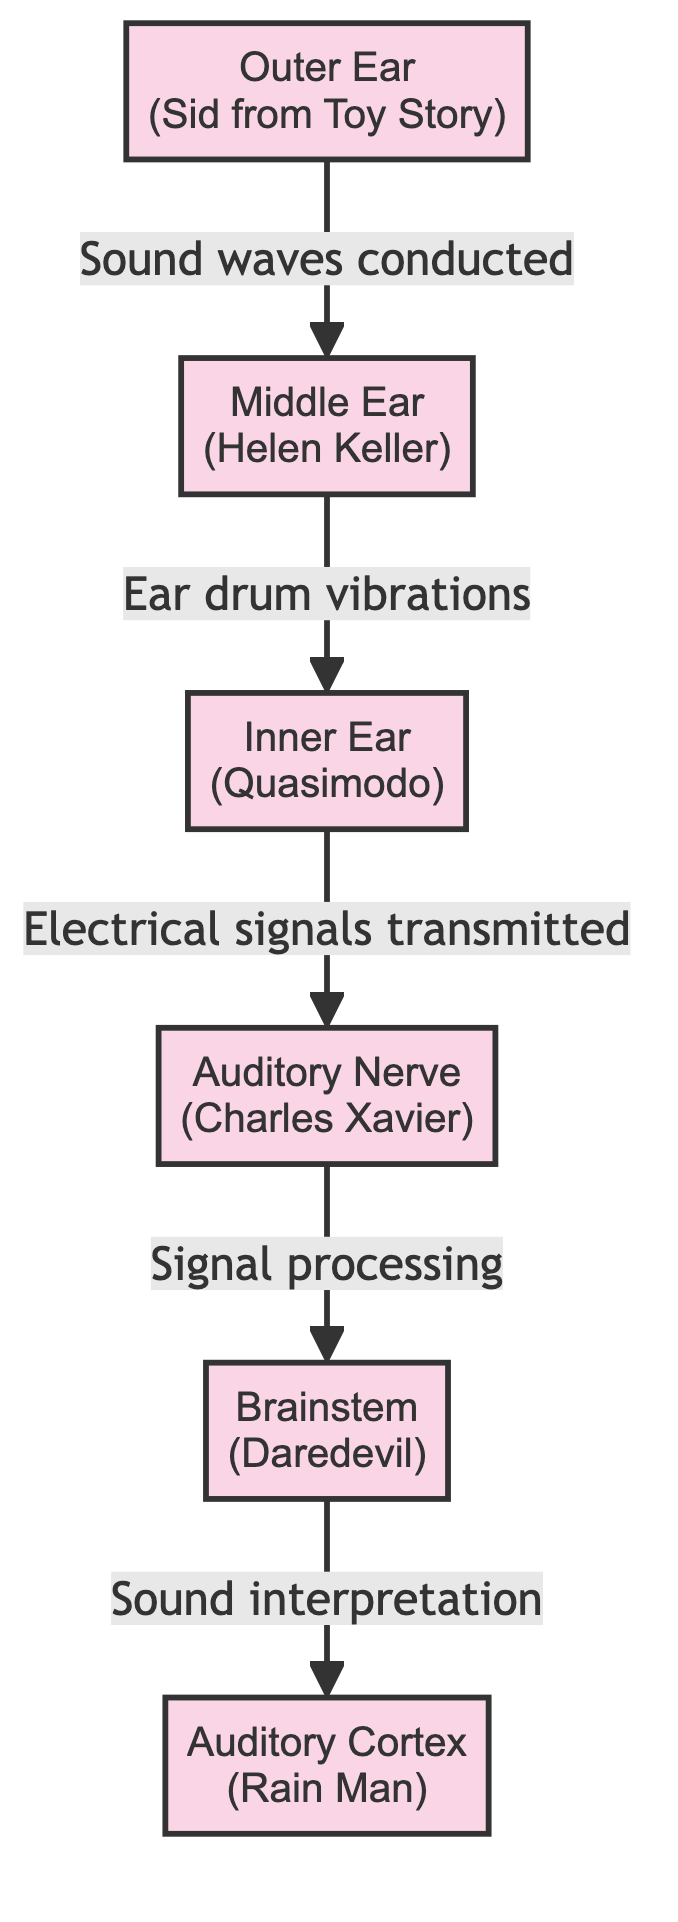What character is associated with the Outer Ear? The Outer Ear node is labeled with the character Sid from Toy Story.
Answer: Sid from Toy Story How many nodes are in the diagram? There are six nodes: Outer Ear, Middle Ear, Inner Ear, Auditory Nerve, Brainstem, and Auditory Cortex.
Answer: Six What is the relationship between the Middle Ear and the Inner Ear? The Middle Ear node shows an arrow leading to the Inner Ear symbolizing that ear drum vibrations are conducted from Middle Ear to Inner Ear.
Answer: Ear drum vibrations Which character is associated with the Auditory Cortex? The Auditory Cortex node is associated with the character Rain Man.
Answer: Rain Man What type of signal is transmitted from the Inner Ear to the Auditory Nerve? The diagram states that electrical signals are transmitted from the Inner Ear to the Auditory Nerve.
Answer: Electrical signals Which character represents the Brainstem in the diagram? The Brainstem node depicts the character Daredevil.
Answer: Daredevil What follows after signals are processed by the Auditory Nerve? After signal processing in the Auditory Nerve, the signals proceed to the Brainstem, as shown in the diagram flow.
Answer: Brainstem What is the flow direction of sound from the Outer Ear to the Auditory Cortex? The sound flow goes from the Outer Ear to the Middle Ear, then to the Inner Ear, followed by the Auditory Nerve, then to the Brainstem, and finally to the Auditory Cortex.
Answer: Outer Ear → Middle Ear → Inner Ear → Auditory Nerve → Brainstem → Auditory Cortex What is depicted by the connection between the Brainstem and the Auditory Cortex? The connection indicates sound interpretation occurring at the Brainstem before reaching the Auditory Cortex.
Answer: Sound interpretation 